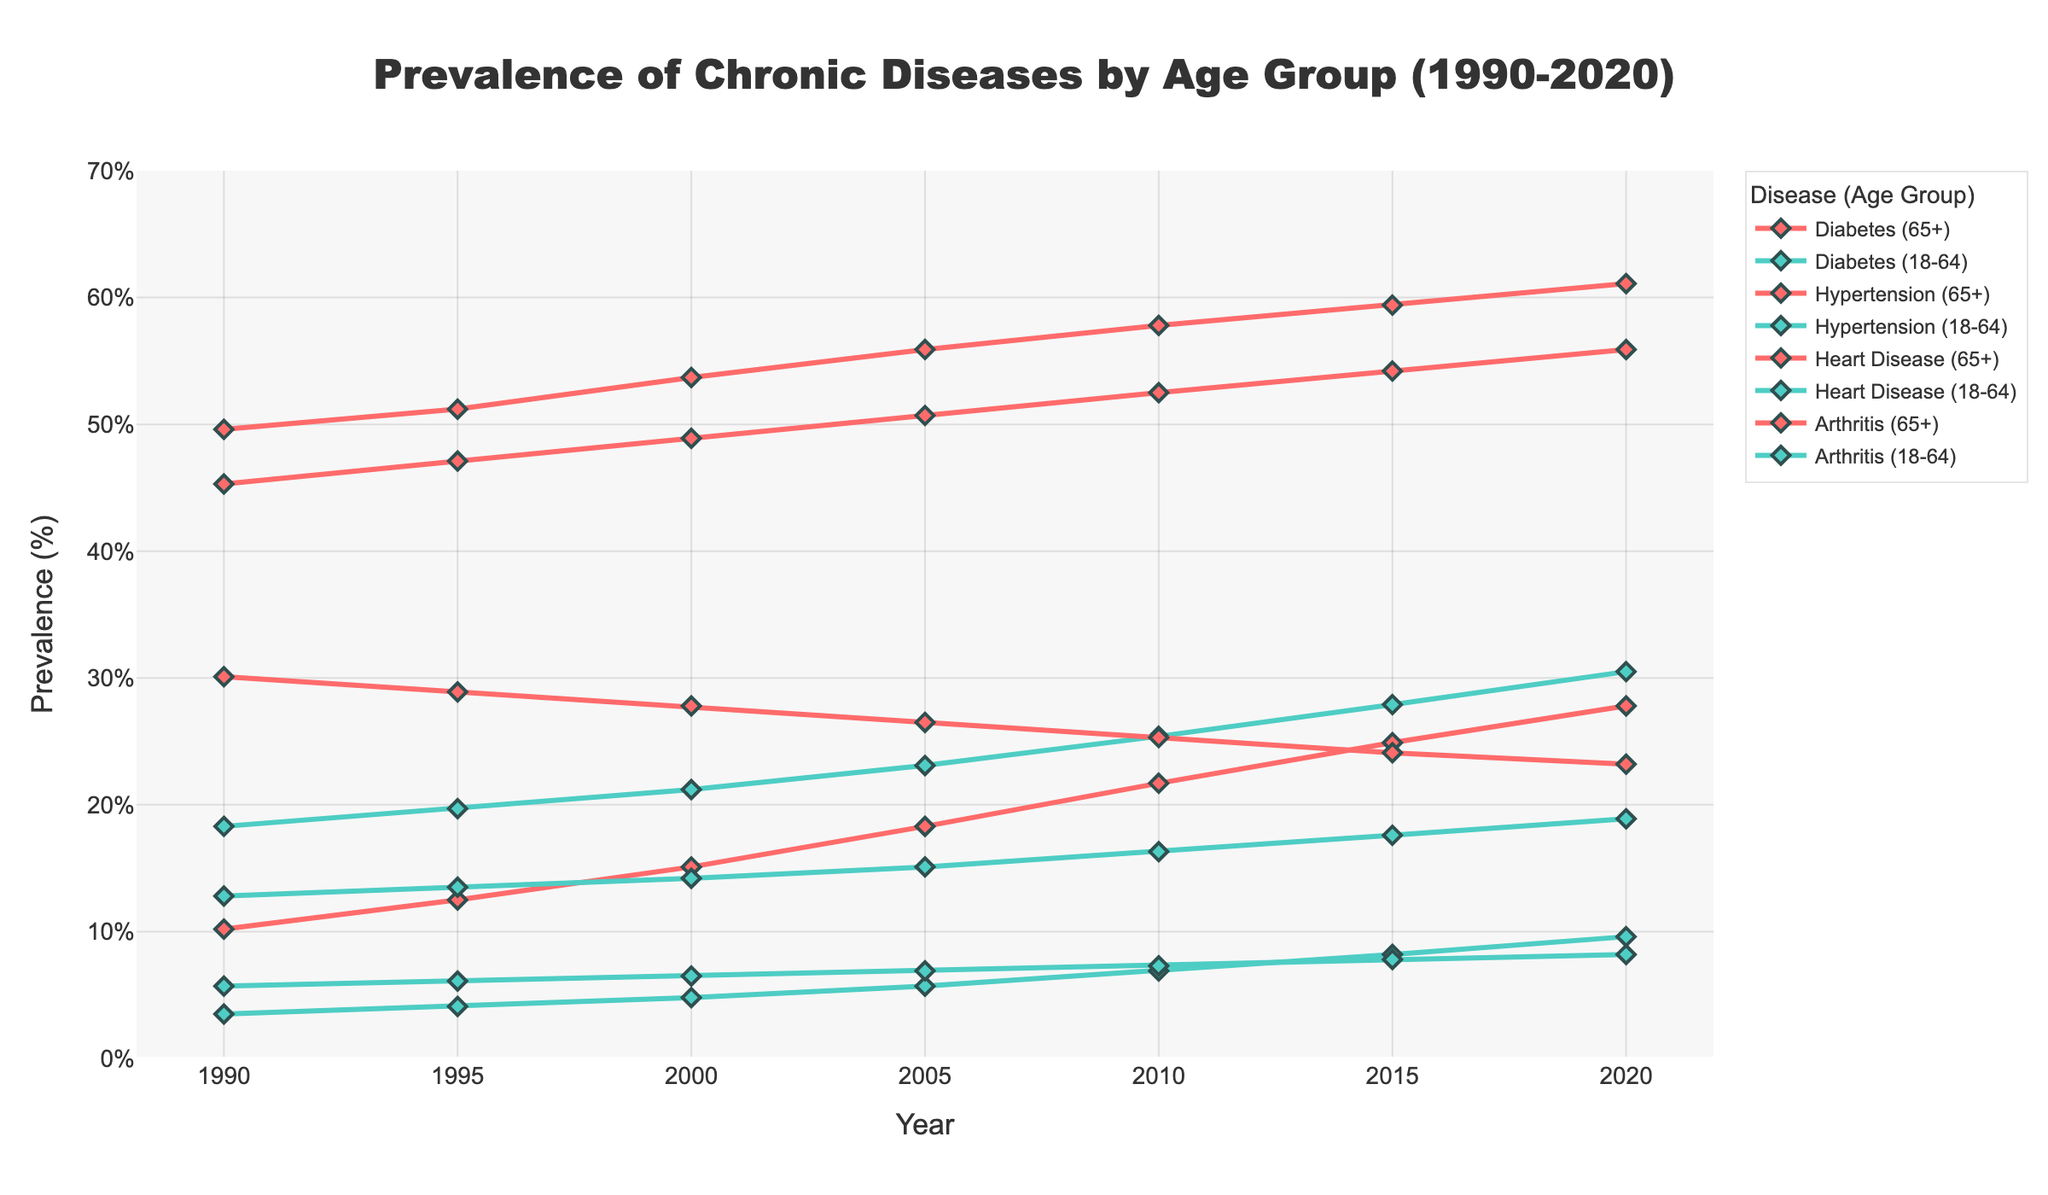What is the prevalence of Diabetes in the 65+ age group in 2010? Look at the point for Diabetes (65+) in the year 2010 on the chart to find its prevalence.
Answer: 21.7% Which age group had a higher prevalence of Hypertension in 2005? Compare the points for Hypertension (65+) and Hypertension (18-64) in 2005. The one that appears higher on the chart indicates the higher prevalence.
Answer: 65+ What is the difference in the prevalence of Heart Disease between the 65+ and 18-64 age groups in 2020? Find and subtract the prevalence of Heart Disease (18-64) from Heart Disease (65+) in 2020.
Answer: 15% Which disease saw the largest increase in prevalence for the 18-64 age group from 1990 to 2020? Compare the differences in prevalence for Diabetes, Hypertension, Heart Disease, and Arthritis for the 18-64 age group between 1990 and 2020 by looking at the increase in height of the lines.
Answer: Hypertension Calculate the average prevalence of Arthritis in the 65+ age group over the 30 years presented. Find the prevalence values for Arthritis (65+) for each year and calculate the average: (45.3 + 47.1 + 48.9 + 50.7 + 52.5 + 54.2 + 55.9) / 7.
Answer: 50.8% Which chronic disease had the lowest prevalence for the 18-64 age group in 2000? Look at the points for Diabetes, Hypertension, Heart Disease, and Arthritis in the 18-64 age group in 2000 and find the lowest one.
Answer: Heart Disease How does the prevalence of Diabetes in 1995 for the 65+ age group compare with the 18-64 age group? Compare the two points for Diabetes in 1995 for the two age groups.
Answer: Higher in 65+ age group What is the trend in prevalence for Hypertension in both age groups from 1990 to 2020? Examine the lines for Hypertension (65+) and Hypertension (18-64) over the time span and consider if they are increasing, decreasing, or remaining constant.
Answer: Increasing In which year did Heart Disease in the 65+ age group see the steepest decline? Look for the year-to-year changes in the line for Heart Disease (65+); the steepest decline is where the line decreases the most.
Answer: 1995 By how much did the prevalence of Arthritis in the 18-64 age group increase from 1990 to 2010? Subtract the prevalence in 1990 from the prevalence in 2010 for Arthritis (18-64).
Answer: 3.5% 